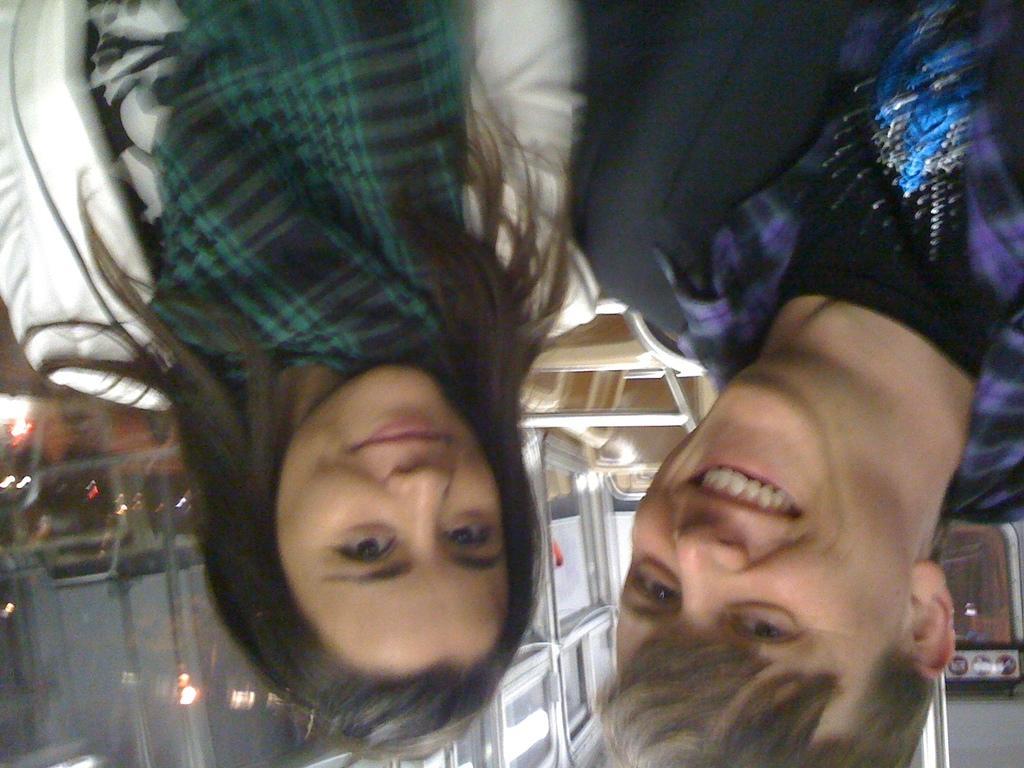Can you describe this image briefly? In this image we can see two persons and they are smiling. In the background we can see lights and few objects. 